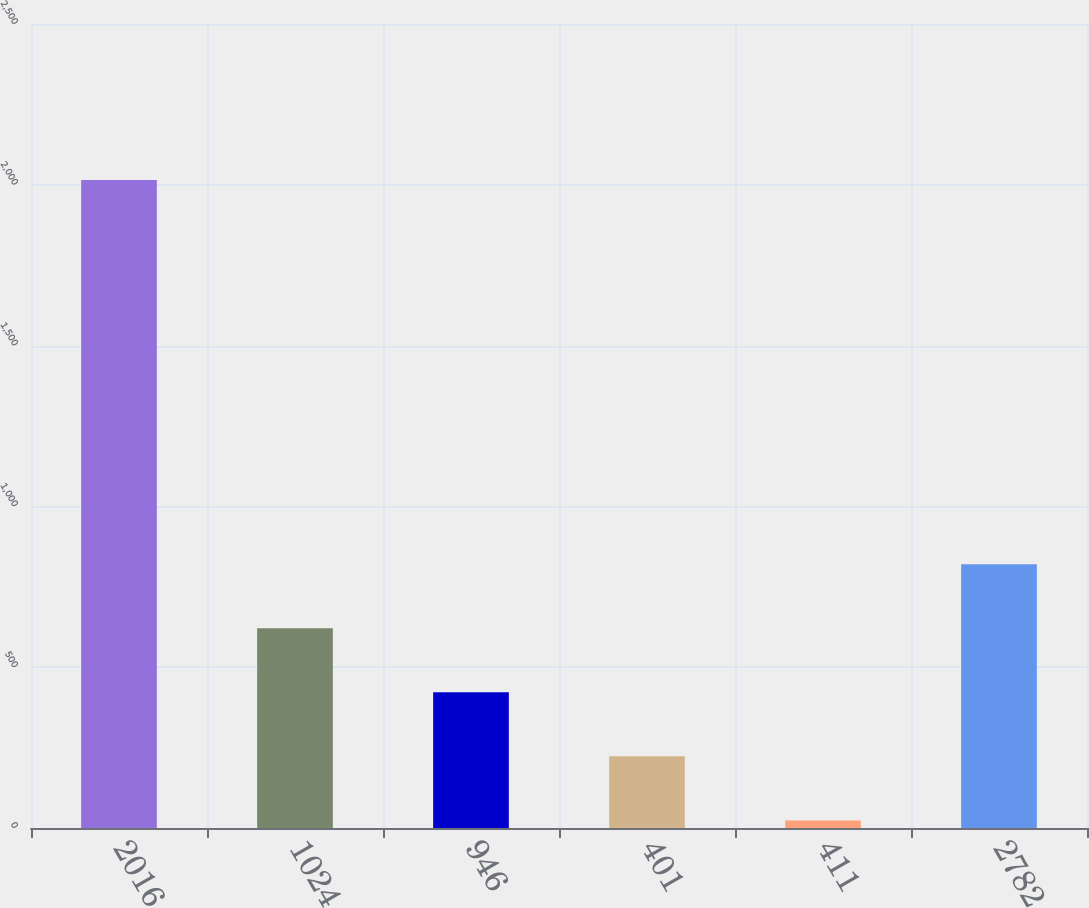Convert chart. <chart><loc_0><loc_0><loc_500><loc_500><bar_chart><fcel>2016<fcel>1024<fcel>946<fcel>401<fcel>411<fcel>2782<nl><fcel>2015<fcel>621.09<fcel>421.96<fcel>222.83<fcel>23.7<fcel>820.22<nl></chart> 